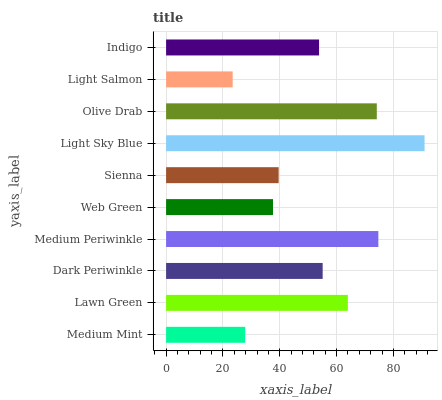Is Light Salmon the minimum?
Answer yes or no. Yes. Is Light Sky Blue the maximum?
Answer yes or no. Yes. Is Lawn Green the minimum?
Answer yes or no. No. Is Lawn Green the maximum?
Answer yes or no. No. Is Lawn Green greater than Medium Mint?
Answer yes or no. Yes. Is Medium Mint less than Lawn Green?
Answer yes or no. Yes. Is Medium Mint greater than Lawn Green?
Answer yes or no. No. Is Lawn Green less than Medium Mint?
Answer yes or no. No. Is Dark Periwinkle the high median?
Answer yes or no. Yes. Is Indigo the low median?
Answer yes or no. Yes. Is Indigo the high median?
Answer yes or no. No. Is Medium Mint the low median?
Answer yes or no. No. 